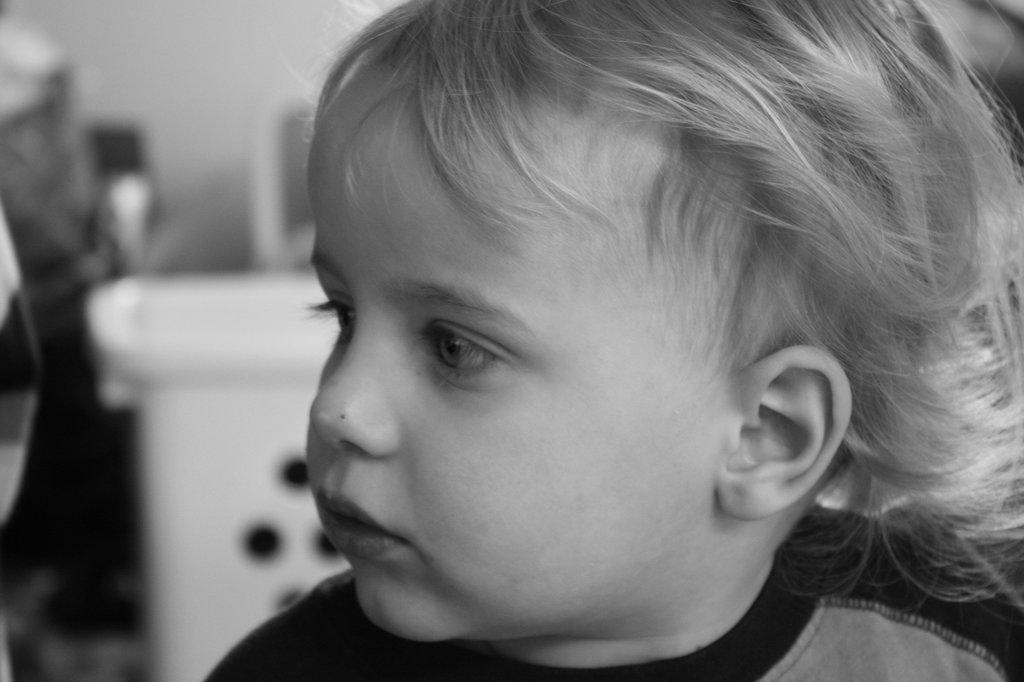What is the color scheme of the image? The image is black and white. Who is the main subject in the image? There is a boy in the image. What is the boy wearing? The boy is wearing a t-shirt. How many rabbits can be seen in the image? There are no rabbits present in the image. What advice does the boy's dad give him in the image? There is no mention of the boy's dad or any advice in the image. 